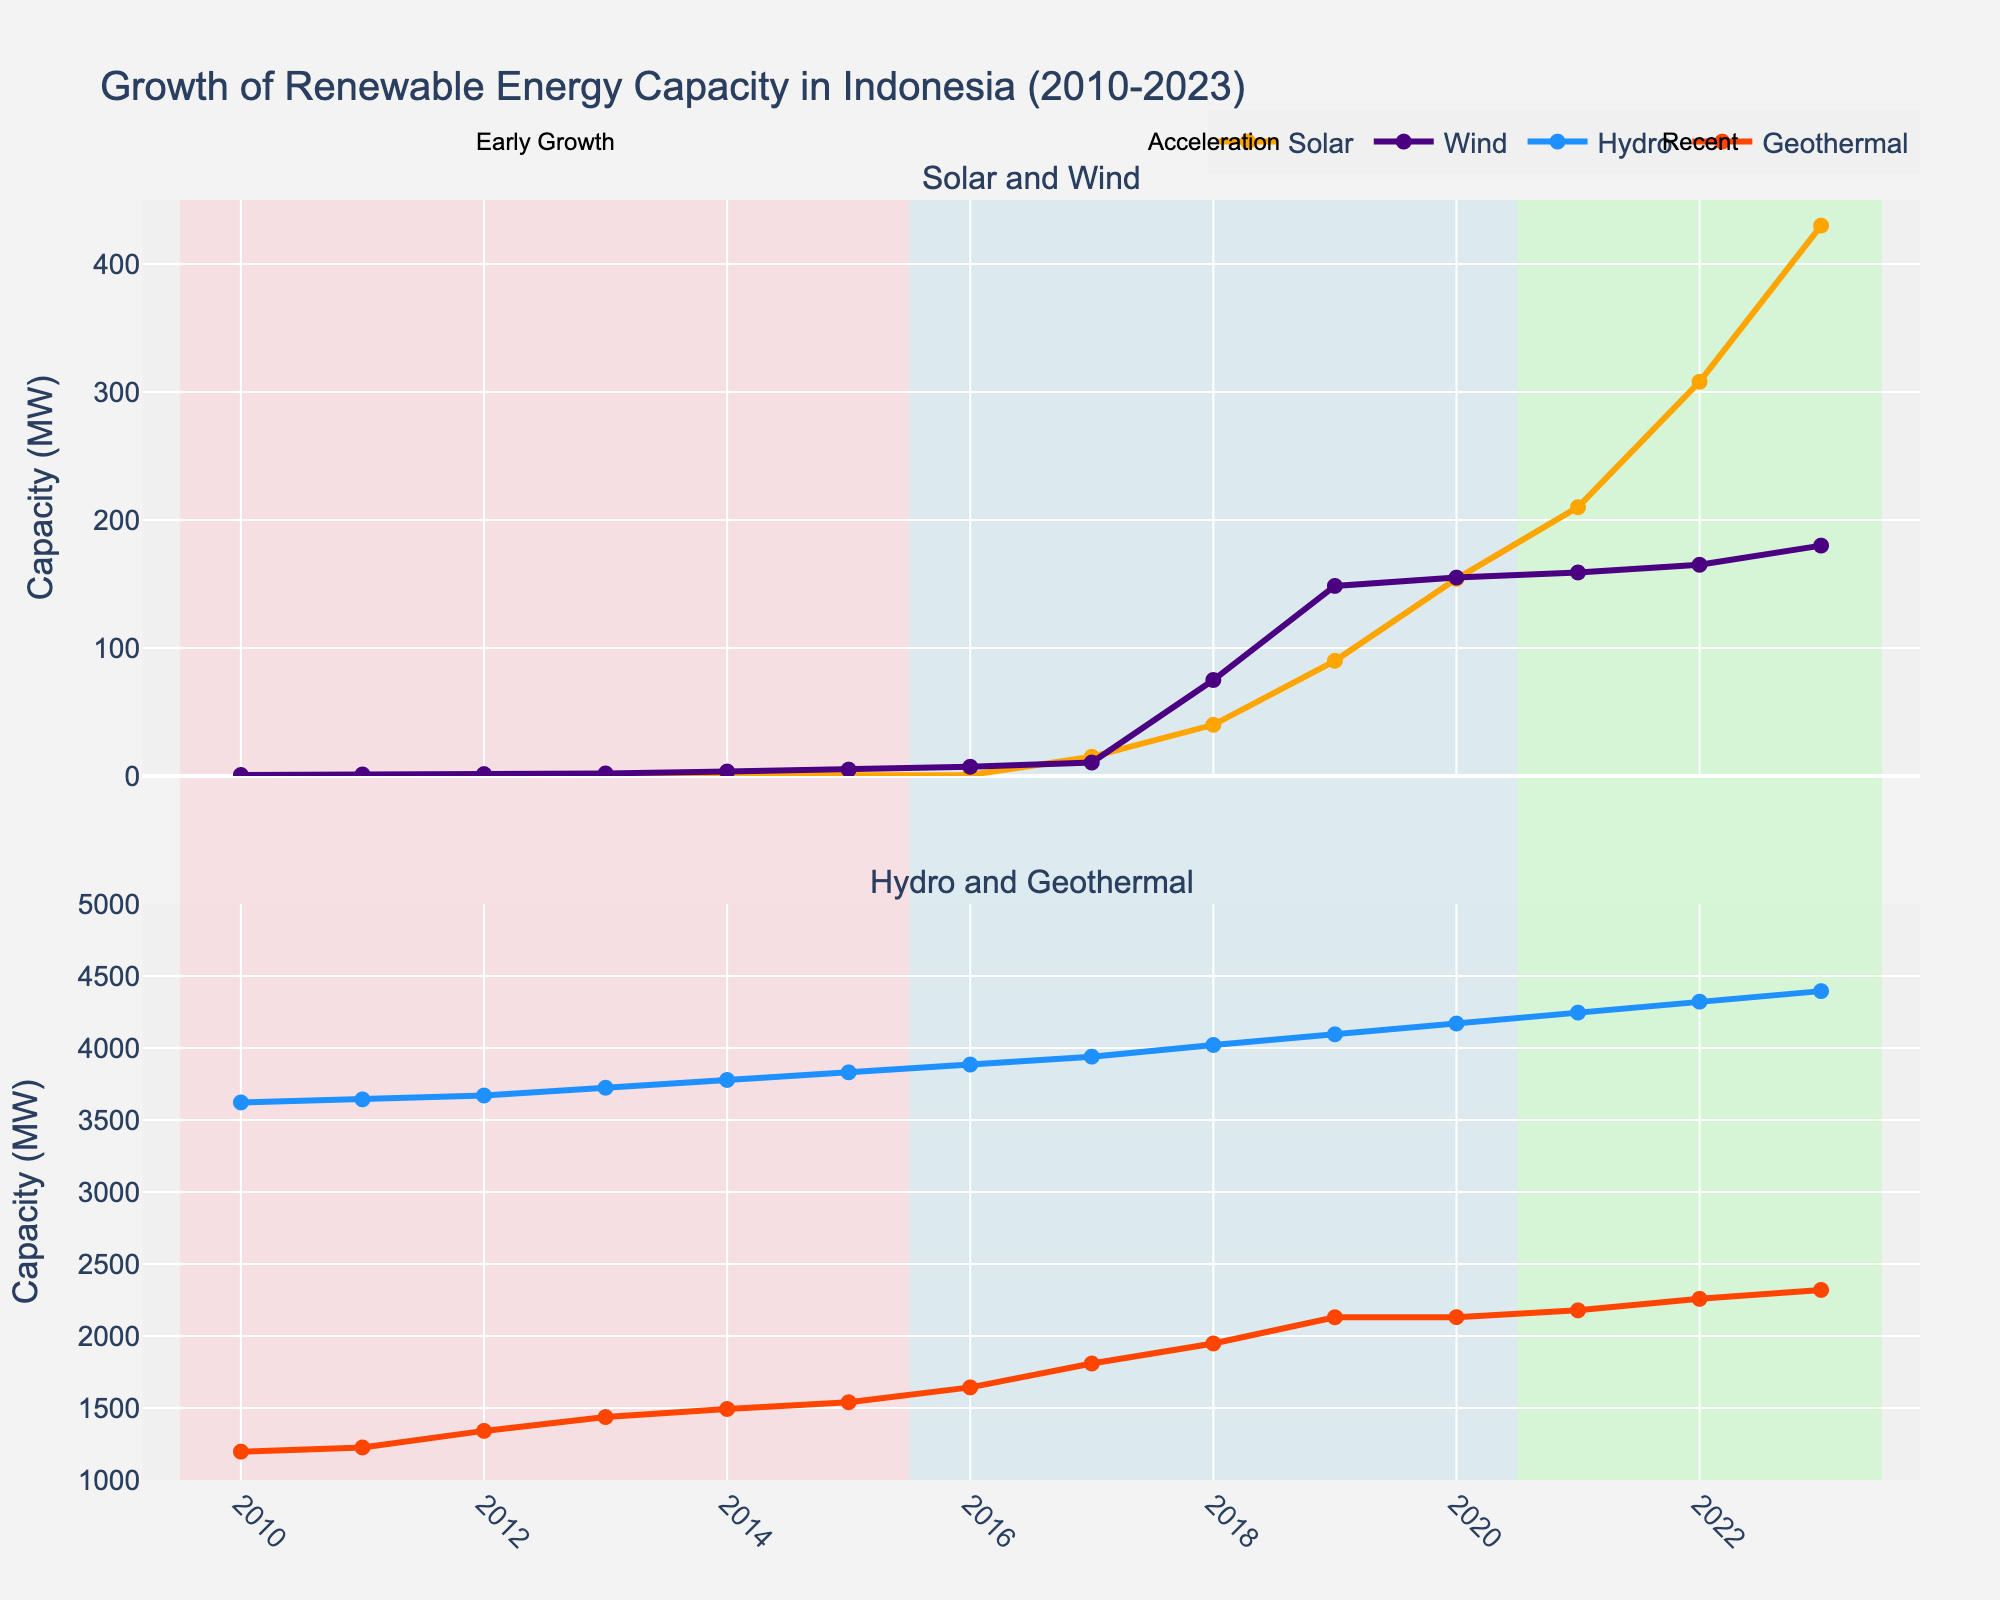How did the capacity of solar energy increase from 2010 to 2023? From the plot, the solar capacity started at 0.01 MW in 2010 and increased to 430.0 MW in 2023. The increments were gradual until 2016 and more significant afterward, showing a steep rise by 2023.
Answer: It increased from 0.01 MW to 430.0 MW Which renewable energy source showed the most rapid increase during the "Acceleration" period (2016-2020)? By observing the highlighted period between 2016-2020, solar energy shows the steepest slope, indicating the most rapid increase in capacity.
Answer: Solar energy What is the combined capacity of hydro and geothermal energy in 2023? From the values shown for 2023, hydro has a capacity of 4395 MW and geothermal has 2320 MW. Adding these gives 4395 + 2320 = 6715 MW.
Answer: 6715 MW Compare the capacities of wind and geothermal energy in 2021. Which one is higher and by how much? In 2021, wind energy capacity is 159 MW, and geothermal capacity is 2178 MW. The difference is 2178 - 159 = 2019 MW.
Answer: Geothermal by 2019 MW What trend can you observe in the hydro energy capacity from 2010 to 2023? Observing the plot, the hydro energy capacity shows a consistent and gradual increase from 3622 MW in 2010 to 4395 MW in 2023, indicating steady growth over the years.
Answer: Steady growth Which year saw the largest single-year increase in solar energy capacity, and what was the increase? The plot shows that from 2017 to 2018, the solar capacity increased from 15 MW to 40 MW, which is a 25 MW increase. This is the largest single-year increase.
Answer: 2017-2018, 25 MW How much did wind energy capacity increase between 2018 and 2019? In the graph, wind energy capacity increased from 75 MW in 2018 to 148.5 MW in 2019. The increase is 148.5 - 75 = 73.5 MW.
Answer: 73.5 MW Which energy source had the highest capacity in 2020, and what was it? By looking at the values for 2020, hydro energy had the highest capacity at 4170 MW.
Answer: Hydro, 4170 MW Summarize the capacity trend for geothermal energy between 2010 and 2023. Geothermal energy capacity increased steadily from 1197 MW in 2010 to 2320 MW in 2023, showing a consistent increment without any steep changes.
Answer: Steady increase from 1197 MW to 2320 MW In 2015, how did solar and wind capacities compare, and which was higher? In 2015, the plot shows solar energy at 0.25 MW and wind energy at 5.0 MW. Wind capacity was higher.
Answer: Wind was higher at 5.0 MW 